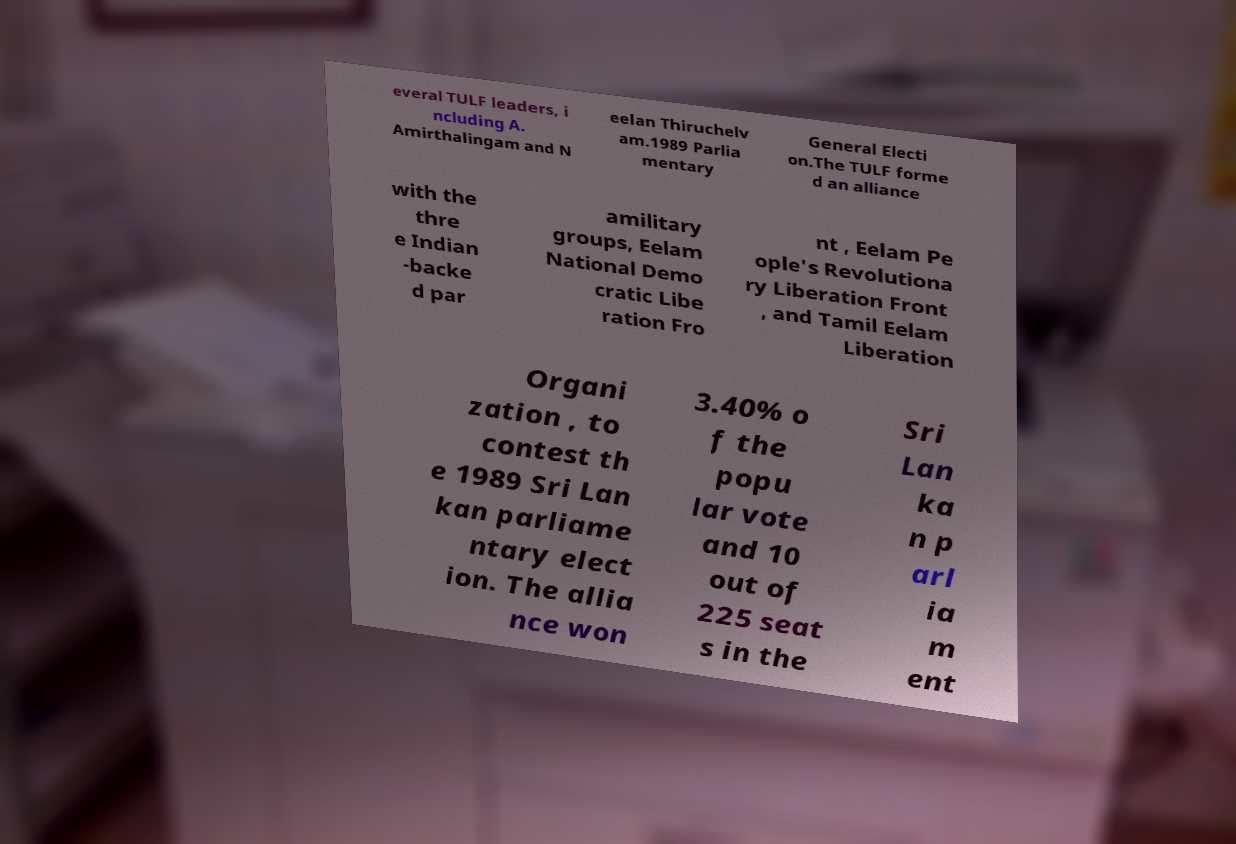Can you accurately transcribe the text from the provided image for me? everal TULF leaders, i ncluding A. Amirthalingam and N eelan Thiruchelv am.1989 Parlia mentary General Electi on.The TULF forme d an alliance with the thre e Indian -backe d par amilitary groups, Eelam National Demo cratic Libe ration Fro nt , Eelam Pe ople's Revolutiona ry Liberation Front , and Tamil Eelam Liberation Organi zation , to contest th e 1989 Sri Lan kan parliame ntary elect ion. The allia nce won 3.40% o f the popu lar vote and 10 out of 225 seat s in the Sri Lan ka n p arl ia m ent 